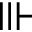Convert formula to latex. <formula><loc_0><loc_0><loc_500><loc_500>\ V v d a s h</formula> 